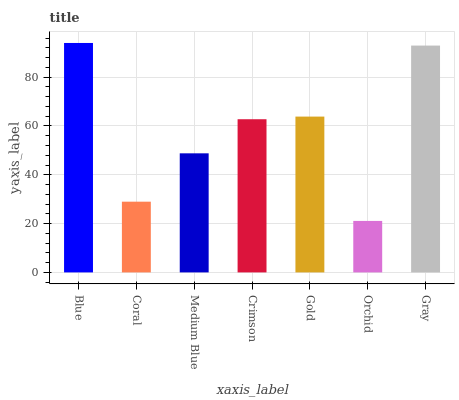Is Orchid the minimum?
Answer yes or no. Yes. Is Blue the maximum?
Answer yes or no. Yes. Is Coral the minimum?
Answer yes or no. No. Is Coral the maximum?
Answer yes or no. No. Is Blue greater than Coral?
Answer yes or no. Yes. Is Coral less than Blue?
Answer yes or no. Yes. Is Coral greater than Blue?
Answer yes or no. No. Is Blue less than Coral?
Answer yes or no. No. Is Crimson the high median?
Answer yes or no. Yes. Is Crimson the low median?
Answer yes or no. Yes. Is Gold the high median?
Answer yes or no. No. Is Coral the low median?
Answer yes or no. No. 